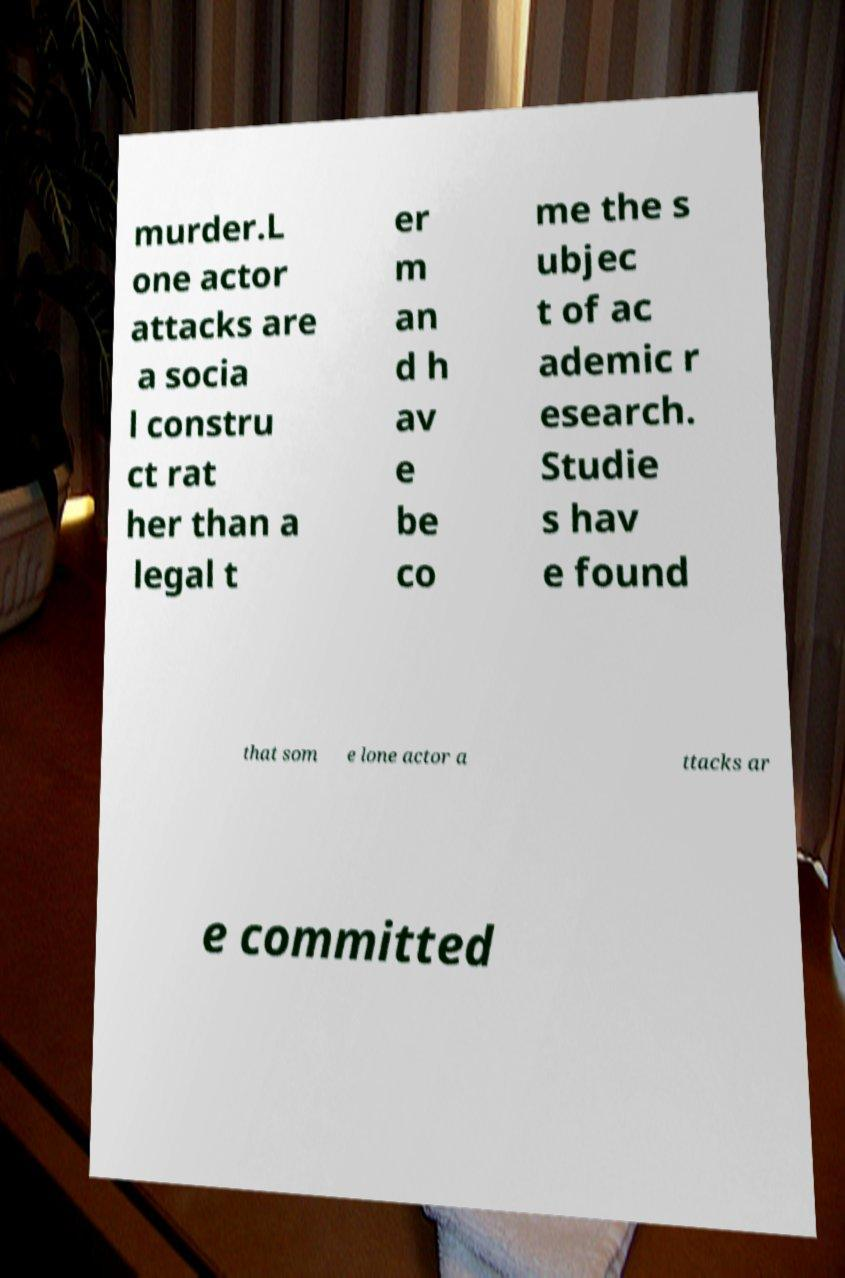Could you assist in decoding the text presented in this image and type it out clearly? murder.L one actor attacks are a socia l constru ct rat her than a legal t er m an d h av e be co me the s ubjec t of ac ademic r esearch. Studie s hav e found that som e lone actor a ttacks ar e committed 